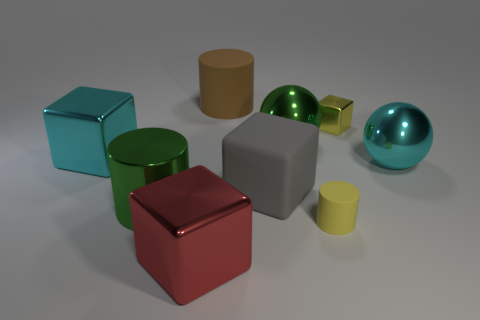There is a yellow object that is in front of the ball that is behind the cyan thing to the left of the large red object; what shape is it?
Provide a succinct answer. Cylinder. Is the number of green metal cylinders behind the large green cylinder greater than the number of green things?
Your response must be concise. No. Does the cyan object left of the big red metallic block have the same shape as the tiny yellow matte thing?
Your response must be concise. No. There is a red cube that is to the left of the tiny yellow matte object; what is it made of?
Your answer should be very brief. Metal. What number of other small gray shiny things have the same shape as the gray thing?
Your answer should be very brief. 0. There is a big green ball that is in front of the metallic block on the right side of the brown rubber object; what is it made of?
Your response must be concise. Metal. The metal thing that is the same color as the big shiny cylinder is what shape?
Make the answer very short. Sphere. Are there any small brown cubes made of the same material as the red thing?
Keep it short and to the point. No. There is a yellow metal object; what shape is it?
Provide a succinct answer. Cube. What number of big metallic cubes are there?
Your answer should be very brief. 2. 